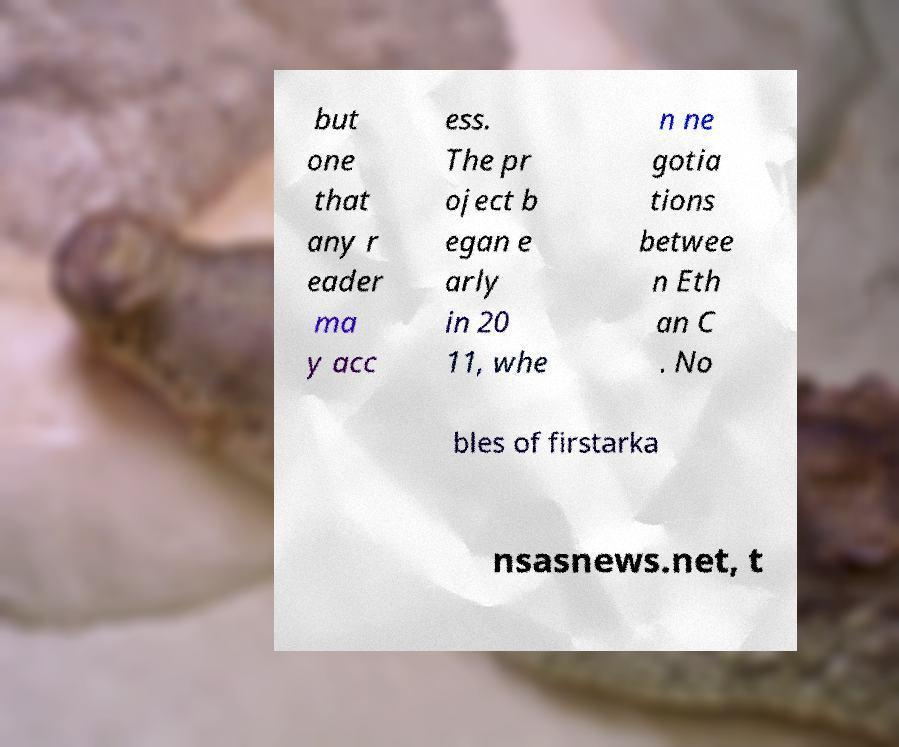Please identify and transcribe the text found in this image. but one that any r eader ma y acc ess. The pr oject b egan e arly in 20 11, whe n ne gotia tions betwee n Eth an C . No bles of firstarka nsasnews.net, t 